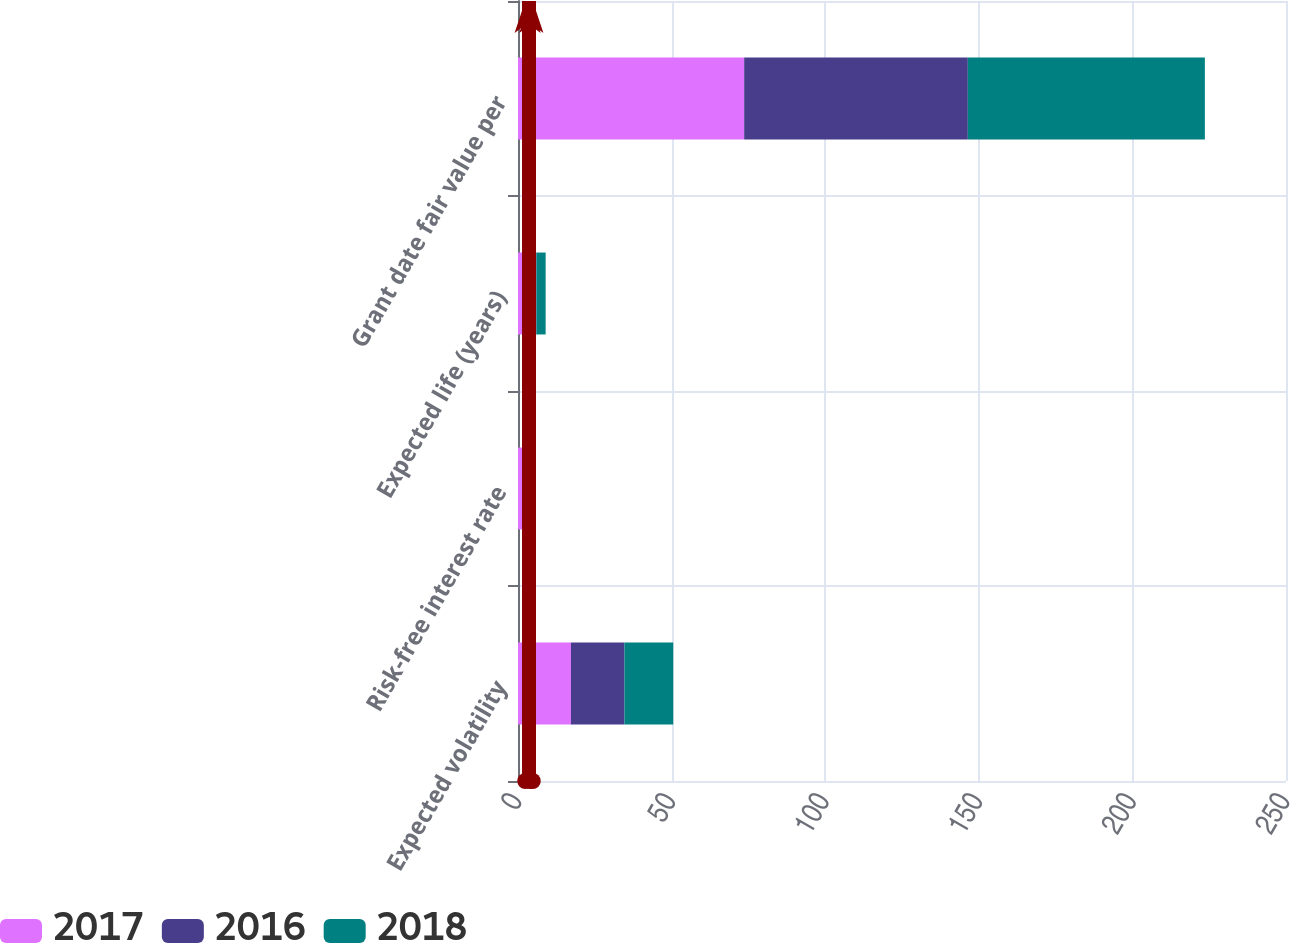Convert chart. <chart><loc_0><loc_0><loc_500><loc_500><stacked_bar_chart><ecel><fcel>Expected volatility<fcel>Risk-free interest rate<fcel>Expected life (years)<fcel>Grant date fair value per<nl><fcel>2017<fcel>17.23<fcel>2.36<fcel>3<fcel>73.62<nl><fcel>2016<fcel>17.4<fcel>1.53<fcel>3<fcel>72.81<nl><fcel>2018<fcel>15.9<fcel>0.91<fcel>3<fcel>77.16<nl></chart> 